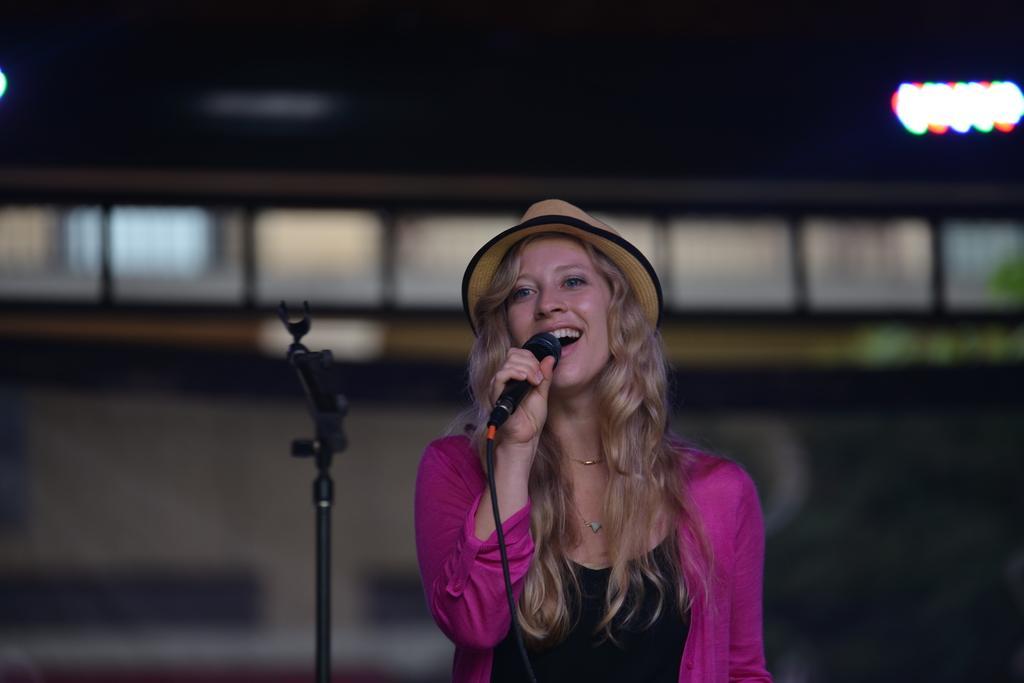Please provide a concise description of this image. In this image I see a woman who is holding a mic and she is wearing a pink and black dress and she is also wearing a hat, I can also see a tripod in front of her. In the background I see the lights over here. 